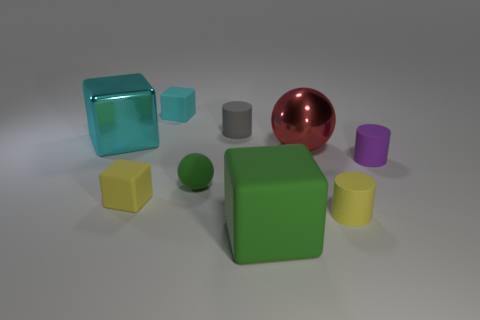The red sphere that is made of the same material as the large cyan cube is what size?
Provide a succinct answer. Large. Do the large green object and the cyan matte thing have the same shape?
Your response must be concise. Yes. The sphere that is the same size as the purple cylinder is what color?
Provide a short and direct response. Green. What size is the yellow matte object that is the same shape as the purple rubber thing?
Offer a terse response. Small. What shape is the yellow object to the left of the tiny green object?
Your response must be concise. Cube. There is a tiny gray rubber thing; is it the same shape as the large shiny object that is left of the red metal sphere?
Your answer should be very brief. No. Is the number of tiny cyan blocks that are in front of the red metal ball the same as the number of cyan metallic objects that are to the right of the small yellow cube?
Offer a terse response. Yes. The other object that is the same color as the large matte thing is what shape?
Your response must be concise. Sphere. There is a tiny cylinder that is left of the green cube; is its color the same as the small matte block that is behind the purple object?
Keep it short and to the point. No. Are there more small yellow objects that are in front of the small cyan cube than purple metallic cylinders?
Give a very brief answer. Yes. 